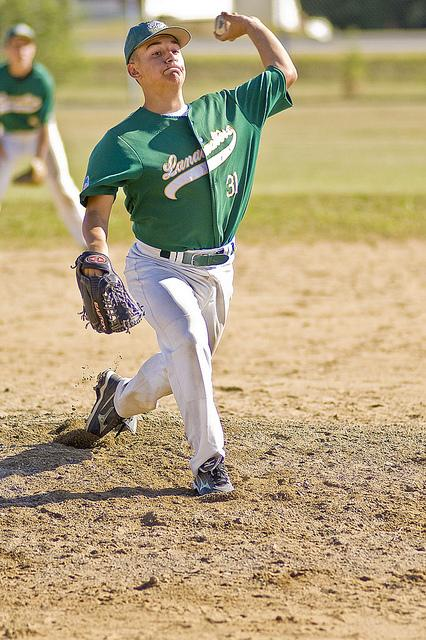Where does this man? baseball 